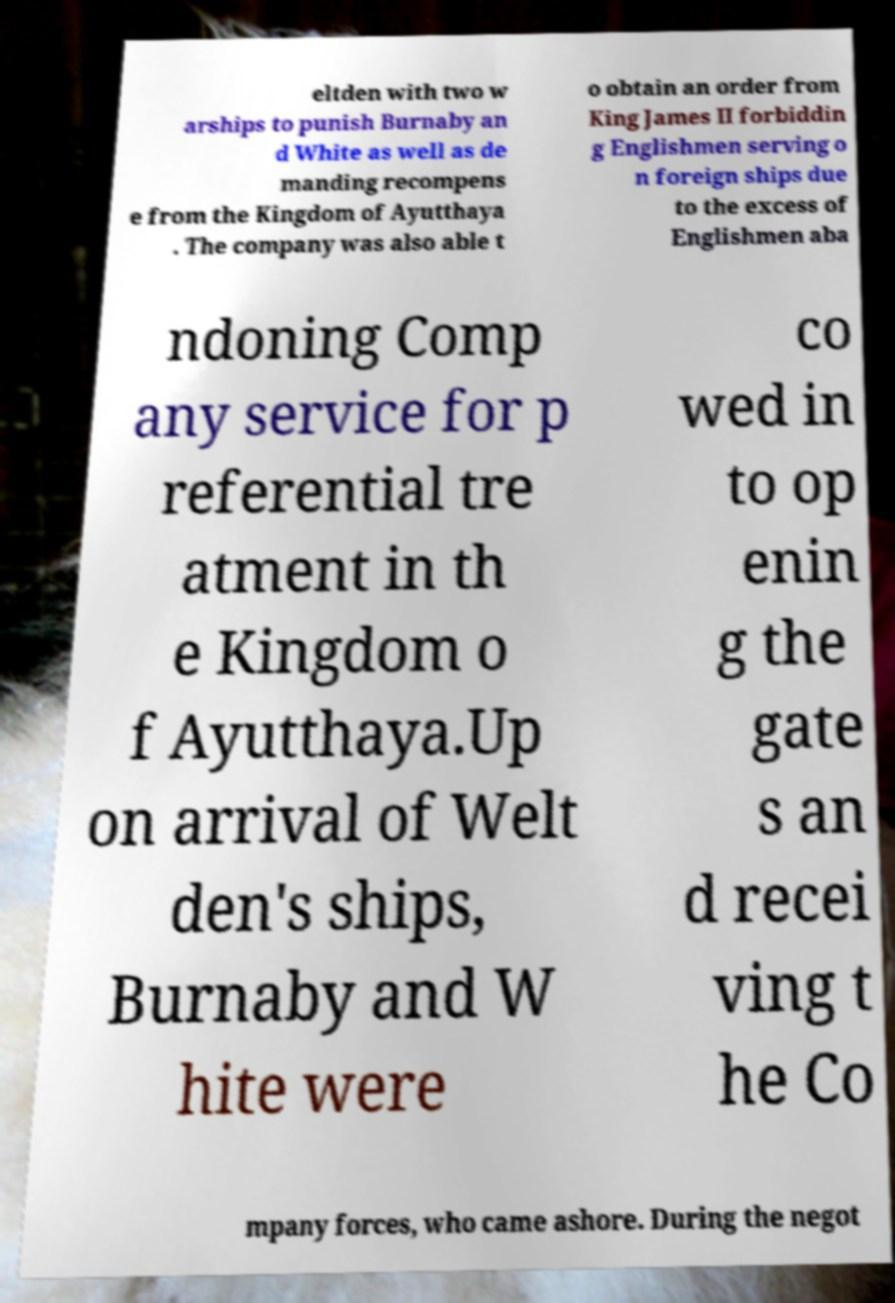Can you accurately transcribe the text from the provided image for me? eltden with two w arships to punish Burnaby an d White as well as de manding recompens e from the Kingdom of Ayutthaya . The company was also able t o obtain an order from King James II forbiddin g Englishmen serving o n foreign ships due to the excess of Englishmen aba ndoning Comp any service for p referential tre atment in th e Kingdom o f Ayutthaya.Up on arrival of Welt den's ships, Burnaby and W hite were co wed in to op enin g the gate s an d recei ving t he Co mpany forces, who came ashore. During the negot 